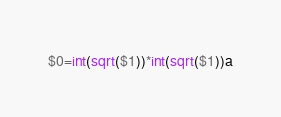Convert code to text. <code><loc_0><loc_0><loc_500><loc_500><_Awk_>$0=int(sqrt($1))*int(sqrt($1))a</code> 